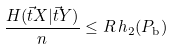<formula> <loc_0><loc_0><loc_500><loc_500>\frac { H ( \vec { t } { X } | \vec { t } { Y } ) } { n } \leq R \, h _ { 2 } ( P _ { \text {b} } )</formula> 